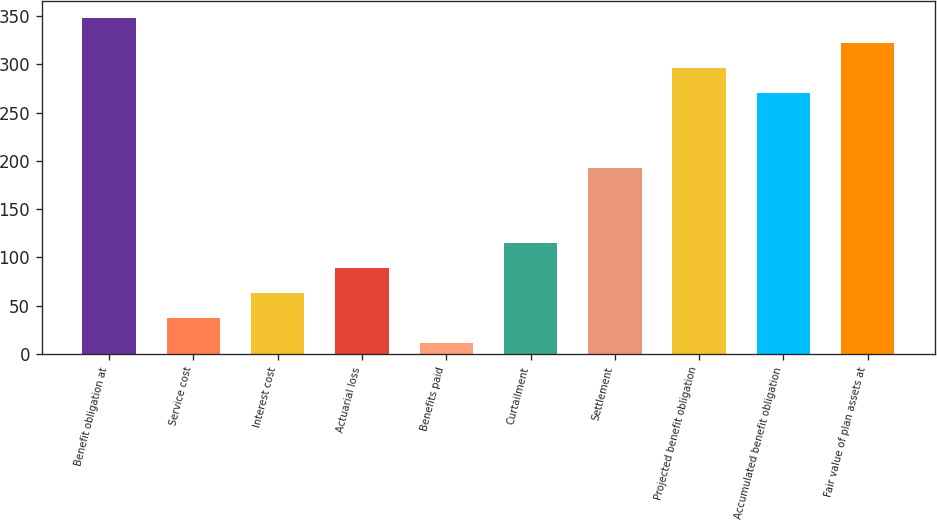Convert chart to OTSL. <chart><loc_0><loc_0><loc_500><loc_500><bar_chart><fcel>Benefit obligation at<fcel>Service cost<fcel>Interest cost<fcel>Actuarial loss<fcel>Benefits paid<fcel>Curtailment<fcel>Settlement<fcel>Projected benefit obligation<fcel>Accumulated benefit obligation<fcel>Fair value of plan assets at<nl><fcel>347.7<fcel>36.9<fcel>62.8<fcel>88.7<fcel>11<fcel>114.6<fcel>192.3<fcel>295.9<fcel>270<fcel>321.8<nl></chart> 